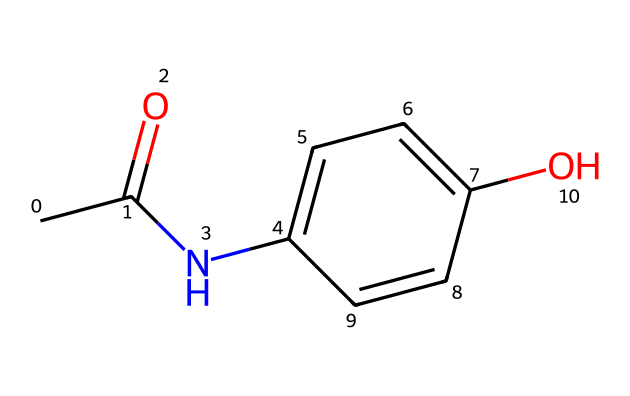What is the molecular formula of paracetamol? To determine the molecular formula, count the number of each type of atom in the given SMILES. The structure has 8 carbon (C) atoms, 9 hydrogen (H) atoms, 1 nitrogen (N) atom, and 1 oxygen (O) atom. This gives us the formula C8H9NO2.
Answer: C8H9NO2 How many rings are present in the structure of paracetamol? By analyzing the provided SMILES representation, we see that there is a cyclic structure represented by "C1", which indicates the start of a ring, and it closes where "C1" is referenced again. There is one ring in the chemical structure.
Answer: 1 What functional groups are present in paracetamol? The SMILES indicates the presence of an amine group (–NH) due to the "N" connected to a carbon, and a hydroxyl group (–OH) from the "O" in the aromatic ring. Therefore, the functional groups present are hydroxyl and amide.
Answer: hydroxyl and amide What type of bonding characterizes the aromatic ring structure? The aromatic ring in paracetamol is characterized by a resonance stabilization due to alternating single and double bonds in a cyclic structure that adheres to Huckel's rule, which is a feature of aromatic compounds. This nature gives it unique stability.
Answer: resonance Why is paracetamol classified as an aromatic compound? Paracetamol is classified as an aromatic compound because it possesses a benzene ring structure, which fulfills the criteria of aromaticity: it is cyclic, planar, fully conjugated with alternating double and single bonds, and follows Huckel's rule (4n + 2 π electrons) with six π electrons.
Answer: benzene ring How many hydrogen atoms are directly bonded to the nitrogen atom? In the structure of paracetamol, the nitrogen (N) is attached to one hydrogen atom as indicated by the representation of "N" joined to one carbon neighbor and has no additional hydrogens indicated. Therefore, one hydrogen atom is directly bonded to nitrogen.
Answer: 1 